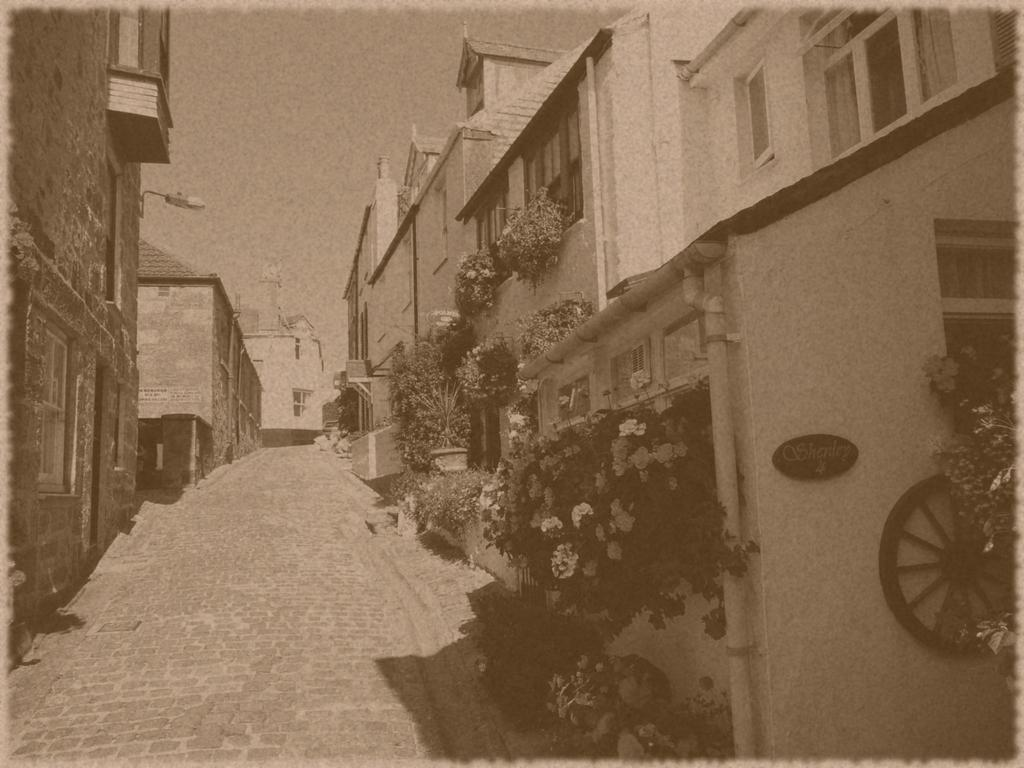What is the main subject of the image? The main subject of the image is a photograph of a path. What can be seen on both sides of the path? There are houses with windows on both sides of the path. What type of vegetation is near the houses? There are plants near the houses. What is visible in the background of the image? The sky is visible in the background of the image. What type of insect can be seen crawling on the stick in the image? There is no insect or stick present in the image. 